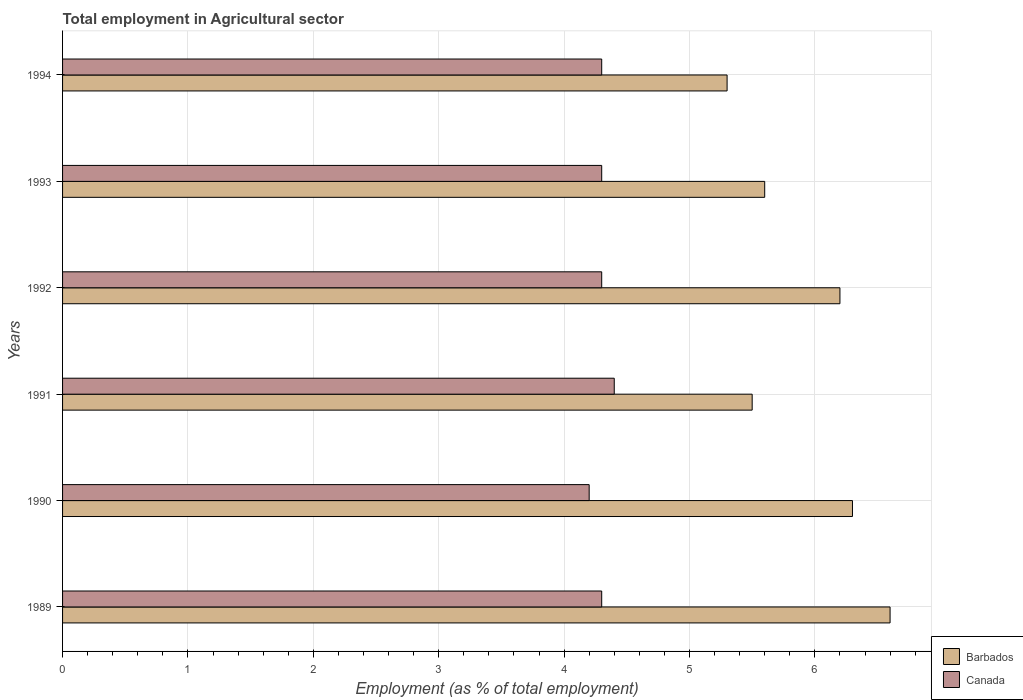How many different coloured bars are there?
Your answer should be very brief. 2. How many groups of bars are there?
Offer a very short reply. 6. In how many cases, is the number of bars for a given year not equal to the number of legend labels?
Ensure brevity in your answer.  0. What is the employment in agricultural sector in Canada in 1992?
Make the answer very short. 4.3. Across all years, what is the maximum employment in agricultural sector in Barbados?
Ensure brevity in your answer.  6.6. Across all years, what is the minimum employment in agricultural sector in Canada?
Offer a very short reply. 4.2. In which year was the employment in agricultural sector in Barbados minimum?
Keep it short and to the point. 1994. What is the total employment in agricultural sector in Canada in the graph?
Ensure brevity in your answer.  25.8. What is the difference between the employment in agricultural sector in Canada in 1990 and that in 1993?
Your answer should be very brief. -0.1. What is the difference between the employment in agricultural sector in Canada in 1992 and the employment in agricultural sector in Barbados in 1991?
Your answer should be very brief. -1.2. What is the average employment in agricultural sector in Canada per year?
Keep it short and to the point. 4.3. In the year 1994, what is the difference between the employment in agricultural sector in Canada and employment in agricultural sector in Barbados?
Offer a very short reply. -1. In how many years, is the employment in agricultural sector in Barbados greater than 2.4 %?
Your answer should be compact. 6. What is the ratio of the employment in agricultural sector in Canada in 1992 to that in 1994?
Offer a terse response. 1. Is the employment in agricultural sector in Canada in 1991 less than that in 1992?
Provide a short and direct response. No. Is the difference between the employment in agricultural sector in Canada in 1989 and 1990 greater than the difference between the employment in agricultural sector in Barbados in 1989 and 1990?
Provide a short and direct response. No. What is the difference between the highest and the second highest employment in agricultural sector in Canada?
Provide a succinct answer. 0.1. What is the difference between the highest and the lowest employment in agricultural sector in Canada?
Your response must be concise. 0.2. In how many years, is the employment in agricultural sector in Canada greater than the average employment in agricultural sector in Canada taken over all years?
Provide a succinct answer. 5. What does the 2nd bar from the top in 1992 represents?
Give a very brief answer. Barbados. What does the 1st bar from the bottom in 1989 represents?
Keep it short and to the point. Barbados. How many bars are there?
Give a very brief answer. 12. Are all the bars in the graph horizontal?
Provide a short and direct response. Yes. How many years are there in the graph?
Offer a very short reply. 6. What is the difference between two consecutive major ticks on the X-axis?
Give a very brief answer. 1. Does the graph contain any zero values?
Provide a succinct answer. No. Does the graph contain grids?
Your answer should be compact. Yes. Where does the legend appear in the graph?
Keep it short and to the point. Bottom right. How many legend labels are there?
Provide a succinct answer. 2. What is the title of the graph?
Give a very brief answer. Total employment in Agricultural sector. Does "Middle East & North Africa (all income levels)" appear as one of the legend labels in the graph?
Keep it short and to the point. No. What is the label or title of the X-axis?
Ensure brevity in your answer.  Employment (as % of total employment). What is the label or title of the Y-axis?
Offer a terse response. Years. What is the Employment (as % of total employment) in Barbados in 1989?
Provide a succinct answer. 6.6. What is the Employment (as % of total employment) of Canada in 1989?
Keep it short and to the point. 4.3. What is the Employment (as % of total employment) of Barbados in 1990?
Offer a terse response. 6.3. What is the Employment (as % of total employment) in Canada in 1990?
Offer a very short reply. 4.2. What is the Employment (as % of total employment) in Barbados in 1991?
Give a very brief answer. 5.5. What is the Employment (as % of total employment) in Canada in 1991?
Give a very brief answer. 4.4. What is the Employment (as % of total employment) of Barbados in 1992?
Make the answer very short. 6.2. What is the Employment (as % of total employment) of Canada in 1992?
Give a very brief answer. 4.3. What is the Employment (as % of total employment) of Barbados in 1993?
Provide a short and direct response. 5.6. What is the Employment (as % of total employment) in Canada in 1993?
Ensure brevity in your answer.  4.3. What is the Employment (as % of total employment) in Barbados in 1994?
Your answer should be very brief. 5.3. What is the Employment (as % of total employment) in Canada in 1994?
Your answer should be very brief. 4.3. Across all years, what is the maximum Employment (as % of total employment) of Barbados?
Give a very brief answer. 6.6. Across all years, what is the maximum Employment (as % of total employment) in Canada?
Provide a succinct answer. 4.4. Across all years, what is the minimum Employment (as % of total employment) in Barbados?
Ensure brevity in your answer.  5.3. Across all years, what is the minimum Employment (as % of total employment) of Canada?
Provide a succinct answer. 4.2. What is the total Employment (as % of total employment) in Barbados in the graph?
Ensure brevity in your answer.  35.5. What is the total Employment (as % of total employment) of Canada in the graph?
Offer a terse response. 25.8. What is the difference between the Employment (as % of total employment) in Canada in 1989 and that in 1990?
Your answer should be very brief. 0.1. What is the difference between the Employment (as % of total employment) of Barbados in 1989 and that in 1991?
Give a very brief answer. 1.1. What is the difference between the Employment (as % of total employment) of Canada in 1989 and that in 1991?
Your answer should be compact. -0.1. What is the difference between the Employment (as % of total employment) in Barbados in 1989 and that in 1993?
Provide a succinct answer. 1. What is the difference between the Employment (as % of total employment) in Canada in 1989 and that in 1993?
Keep it short and to the point. 0. What is the difference between the Employment (as % of total employment) in Barbados in 1990 and that in 1991?
Provide a succinct answer. 0.8. What is the difference between the Employment (as % of total employment) in Canada in 1990 and that in 1991?
Offer a very short reply. -0.2. What is the difference between the Employment (as % of total employment) in Barbados in 1990 and that in 1993?
Your answer should be very brief. 0.7. What is the difference between the Employment (as % of total employment) in Canada in 1990 and that in 1993?
Ensure brevity in your answer.  -0.1. What is the difference between the Employment (as % of total employment) of Barbados in 1991 and that in 1992?
Your answer should be very brief. -0.7. What is the difference between the Employment (as % of total employment) in Barbados in 1991 and that in 1993?
Your response must be concise. -0.1. What is the difference between the Employment (as % of total employment) in Canada in 1991 and that in 1993?
Make the answer very short. 0.1. What is the difference between the Employment (as % of total employment) in Barbados in 1992 and that in 1993?
Offer a very short reply. 0.6. What is the difference between the Employment (as % of total employment) of Canada in 1993 and that in 1994?
Provide a short and direct response. 0. What is the difference between the Employment (as % of total employment) in Barbados in 1989 and the Employment (as % of total employment) in Canada in 1990?
Your response must be concise. 2.4. What is the difference between the Employment (as % of total employment) in Barbados in 1989 and the Employment (as % of total employment) in Canada in 1991?
Provide a succinct answer. 2.2. What is the difference between the Employment (as % of total employment) of Barbados in 1990 and the Employment (as % of total employment) of Canada in 1991?
Make the answer very short. 1.9. What is the difference between the Employment (as % of total employment) of Barbados in 1990 and the Employment (as % of total employment) of Canada in 1992?
Your response must be concise. 2. What is the difference between the Employment (as % of total employment) in Barbados in 1991 and the Employment (as % of total employment) in Canada in 1992?
Make the answer very short. 1.2. What is the difference between the Employment (as % of total employment) of Barbados in 1991 and the Employment (as % of total employment) of Canada in 1993?
Your answer should be compact. 1.2. What is the difference between the Employment (as % of total employment) in Barbados in 1992 and the Employment (as % of total employment) in Canada in 1994?
Provide a succinct answer. 1.9. What is the difference between the Employment (as % of total employment) of Barbados in 1993 and the Employment (as % of total employment) of Canada in 1994?
Make the answer very short. 1.3. What is the average Employment (as % of total employment) of Barbados per year?
Keep it short and to the point. 5.92. What is the average Employment (as % of total employment) of Canada per year?
Your answer should be very brief. 4.3. In the year 1989, what is the difference between the Employment (as % of total employment) in Barbados and Employment (as % of total employment) in Canada?
Your answer should be compact. 2.3. In the year 1990, what is the difference between the Employment (as % of total employment) in Barbados and Employment (as % of total employment) in Canada?
Make the answer very short. 2.1. In the year 1994, what is the difference between the Employment (as % of total employment) of Barbados and Employment (as % of total employment) of Canada?
Your response must be concise. 1. What is the ratio of the Employment (as % of total employment) of Barbados in 1989 to that in 1990?
Your answer should be compact. 1.05. What is the ratio of the Employment (as % of total employment) in Canada in 1989 to that in 1990?
Your response must be concise. 1.02. What is the ratio of the Employment (as % of total employment) of Barbados in 1989 to that in 1991?
Offer a very short reply. 1.2. What is the ratio of the Employment (as % of total employment) in Canada in 1989 to that in 1991?
Provide a succinct answer. 0.98. What is the ratio of the Employment (as % of total employment) of Barbados in 1989 to that in 1992?
Provide a succinct answer. 1.06. What is the ratio of the Employment (as % of total employment) in Barbados in 1989 to that in 1993?
Make the answer very short. 1.18. What is the ratio of the Employment (as % of total employment) in Barbados in 1989 to that in 1994?
Provide a succinct answer. 1.25. What is the ratio of the Employment (as % of total employment) in Barbados in 1990 to that in 1991?
Provide a succinct answer. 1.15. What is the ratio of the Employment (as % of total employment) of Canada in 1990 to that in 1991?
Keep it short and to the point. 0.95. What is the ratio of the Employment (as % of total employment) of Barbados in 1990 to that in 1992?
Keep it short and to the point. 1.02. What is the ratio of the Employment (as % of total employment) in Canada in 1990 to that in 1992?
Offer a terse response. 0.98. What is the ratio of the Employment (as % of total employment) of Canada in 1990 to that in 1993?
Offer a terse response. 0.98. What is the ratio of the Employment (as % of total employment) in Barbados in 1990 to that in 1994?
Provide a short and direct response. 1.19. What is the ratio of the Employment (as % of total employment) of Canada in 1990 to that in 1994?
Offer a very short reply. 0.98. What is the ratio of the Employment (as % of total employment) of Barbados in 1991 to that in 1992?
Your response must be concise. 0.89. What is the ratio of the Employment (as % of total employment) of Canada in 1991 to that in 1992?
Keep it short and to the point. 1.02. What is the ratio of the Employment (as % of total employment) of Barbados in 1991 to that in 1993?
Make the answer very short. 0.98. What is the ratio of the Employment (as % of total employment) of Canada in 1991 to that in 1993?
Offer a very short reply. 1.02. What is the ratio of the Employment (as % of total employment) in Barbados in 1991 to that in 1994?
Give a very brief answer. 1.04. What is the ratio of the Employment (as % of total employment) in Canada in 1991 to that in 1994?
Make the answer very short. 1.02. What is the ratio of the Employment (as % of total employment) in Barbados in 1992 to that in 1993?
Give a very brief answer. 1.11. What is the ratio of the Employment (as % of total employment) of Canada in 1992 to that in 1993?
Your response must be concise. 1. What is the ratio of the Employment (as % of total employment) of Barbados in 1992 to that in 1994?
Your answer should be very brief. 1.17. What is the ratio of the Employment (as % of total employment) in Barbados in 1993 to that in 1994?
Offer a very short reply. 1.06. What is the difference between the highest and the second highest Employment (as % of total employment) of Barbados?
Ensure brevity in your answer.  0.3. What is the difference between the highest and the lowest Employment (as % of total employment) of Barbados?
Keep it short and to the point. 1.3. What is the difference between the highest and the lowest Employment (as % of total employment) of Canada?
Your response must be concise. 0.2. 